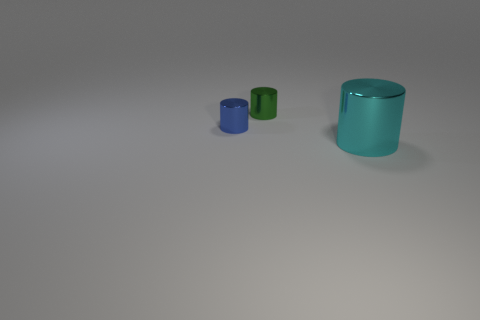Subtract 1 cylinders. How many cylinders are left? 2 Add 3 tiny things. How many objects exist? 6 Subtract all green metallic things. Subtract all small blue metal things. How many objects are left? 1 Add 2 blue metal cylinders. How many blue metal cylinders are left? 3 Add 3 big red rubber balls. How many big red rubber balls exist? 3 Subtract 0 brown cylinders. How many objects are left? 3 